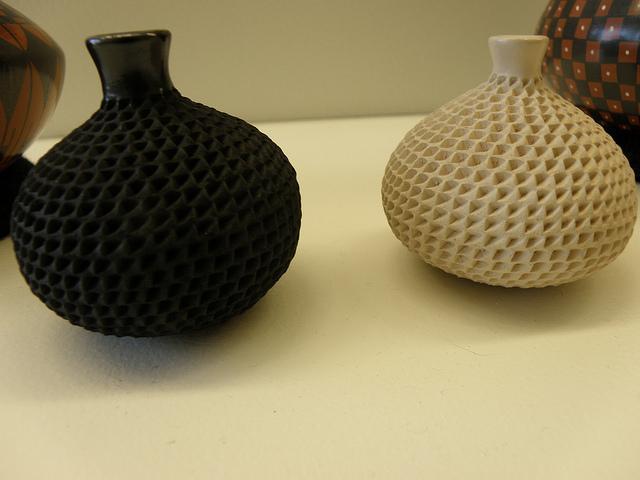How many vases can you see?
Give a very brief answer. 4. 